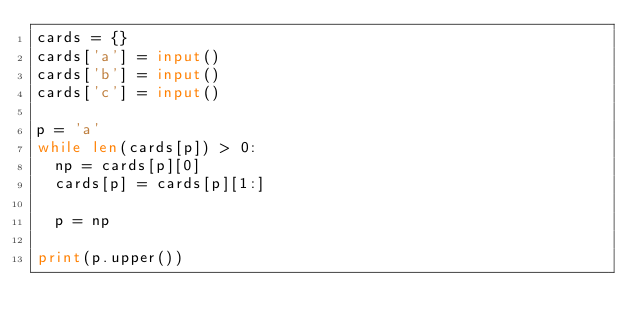Convert code to text. <code><loc_0><loc_0><loc_500><loc_500><_Python_>cards = {}
cards['a'] = input()
cards['b'] = input()
cards['c'] = input()

p = 'a'
while len(cards[p]) > 0:
  np = cards[p][0]
  cards[p] = cards[p][1:]
  
  p = np

print(p.upper())</code> 